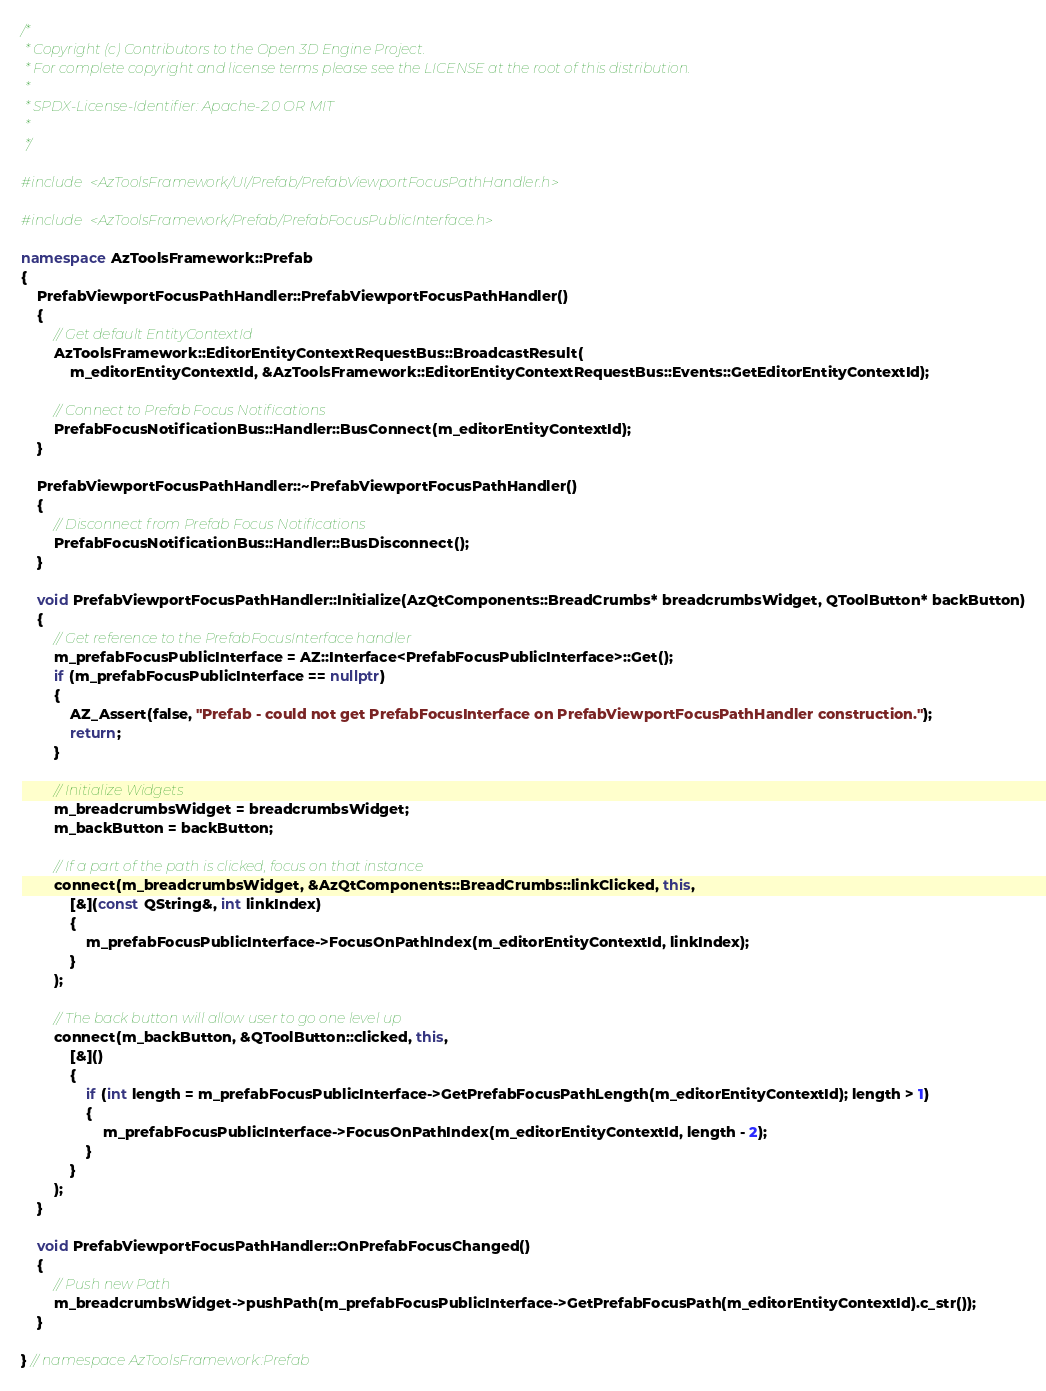Convert code to text. <code><loc_0><loc_0><loc_500><loc_500><_C++_>/*
 * Copyright (c) Contributors to the Open 3D Engine Project.
 * For complete copyright and license terms please see the LICENSE at the root of this distribution.
 *
 * SPDX-License-Identifier: Apache-2.0 OR MIT
 *
 */

#include <AzToolsFramework/UI/Prefab/PrefabViewportFocusPathHandler.h>

#include <AzToolsFramework/Prefab/PrefabFocusPublicInterface.h>

namespace AzToolsFramework::Prefab
{
    PrefabViewportFocusPathHandler::PrefabViewportFocusPathHandler()
    {
        // Get default EntityContextId
        AzToolsFramework::EditorEntityContextRequestBus::BroadcastResult(
            m_editorEntityContextId, &AzToolsFramework::EditorEntityContextRequestBus::Events::GetEditorEntityContextId);

        // Connect to Prefab Focus Notifications
        PrefabFocusNotificationBus::Handler::BusConnect(m_editorEntityContextId);
    }

    PrefabViewportFocusPathHandler::~PrefabViewportFocusPathHandler()
    {
        // Disconnect from Prefab Focus Notifications
        PrefabFocusNotificationBus::Handler::BusDisconnect();
    }

    void PrefabViewportFocusPathHandler::Initialize(AzQtComponents::BreadCrumbs* breadcrumbsWidget, QToolButton* backButton)
    {
        // Get reference to the PrefabFocusInterface handler
        m_prefabFocusPublicInterface = AZ::Interface<PrefabFocusPublicInterface>::Get();
        if (m_prefabFocusPublicInterface == nullptr)
        {
            AZ_Assert(false, "Prefab - could not get PrefabFocusInterface on PrefabViewportFocusPathHandler construction.");
            return;
        }

        // Initialize Widgets
        m_breadcrumbsWidget = breadcrumbsWidget;
        m_backButton = backButton;

        // If a part of the path is clicked, focus on that instance
        connect(m_breadcrumbsWidget, &AzQtComponents::BreadCrumbs::linkClicked, this,
            [&](const QString&, int linkIndex)
            {
                m_prefabFocusPublicInterface->FocusOnPathIndex(m_editorEntityContextId, linkIndex);
            }
        );

        // The back button will allow user to go one level up
        connect(m_backButton, &QToolButton::clicked, this,
            [&]()
            {
                if (int length = m_prefabFocusPublicInterface->GetPrefabFocusPathLength(m_editorEntityContextId); length > 1)
                {
                    m_prefabFocusPublicInterface->FocusOnPathIndex(m_editorEntityContextId, length - 2);
                }
            }
        );
    }

    void PrefabViewportFocusPathHandler::OnPrefabFocusChanged()
    {
        // Push new Path
        m_breadcrumbsWidget->pushPath(m_prefabFocusPublicInterface->GetPrefabFocusPath(m_editorEntityContextId).c_str());
    }

} // namespace AzToolsFramework::Prefab
</code> 